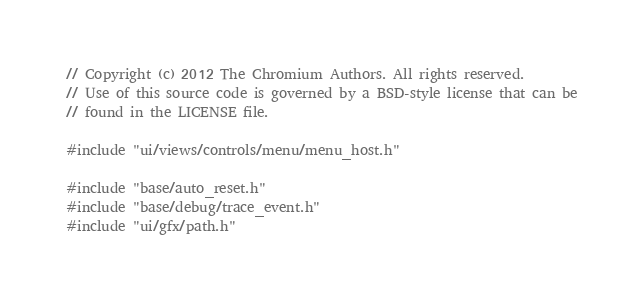<code> <loc_0><loc_0><loc_500><loc_500><_C++_>// Copyright (c) 2012 The Chromium Authors. All rights reserved.
// Use of this source code is governed by a BSD-style license that can be
// found in the LICENSE file.

#include "ui/views/controls/menu/menu_host.h"

#include "base/auto_reset.h"
#include "base/debug/trace_event.h"
#include "ui/gfx/path.h"</code> 